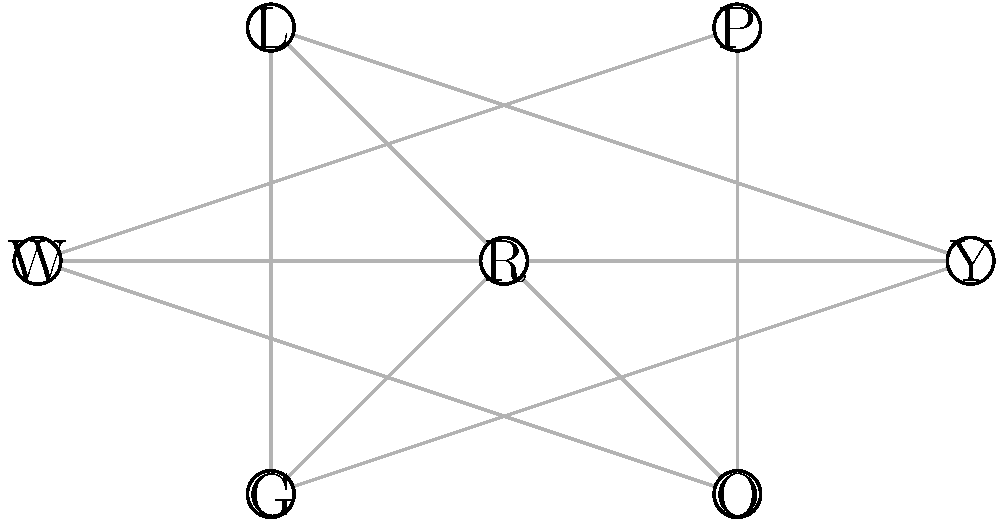In your flower shop, you want to create unique bouquets by combining compatible flowers. The graph represents color compatibility, where connected nodes indicate colors that work well together. Each node represents a flower color: R (Red), P (Pink), Y (Yellow), O (Orange), L (Lavender), W (White), and G (Green). What is the maximum number of different colors you can use in a single bouquet to create a harmonious combination? To find the maximum number of different colors for a harmonious bouquet, we need to find the largest complete subgraph (clique) in the given compatibility graph. Let's approach this step-by-step:

1. Identify all the connections for each color:
   R: connected to P, Y, O, L, W, G
   P: connected to R, Y, L
   Y: connected to R, P, O, W
   O: connected to R, Y
   L: connected to R, P, W
   W: connected to R, Y, L, G
   G: connected to R, W

2. Start with the node with the most connections (R) and try to form the largest clique:
   R-P-Y: forms a triangle, but Y and P are not connected to all others
   R-P-L: forms a triangle, but not all are connected
   R-Y-W: forms a triangle, and all are connected to each other

3. Try to add one more color to R-Y-W:
   R-Y-W-P: P is not connected to W
   R-Y-W-O: O is not connected to W
   R-Y-W-L: L is not connected to Y
   R-Y-W-G: G is not connected to Y

4. We cannot add any more colors to R-Y-W without breaking the compatibility rules.

Therefore, the largest clique in this graph consists of 4 nodes: R, Y, W, and either P or L.
Answer: 4 colors 